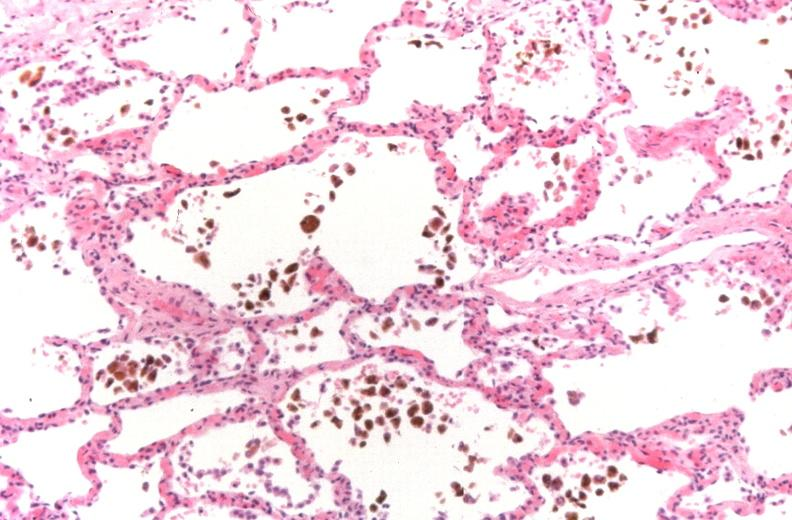what does this image show?
Answer the question using a single word or phrase. Lung 